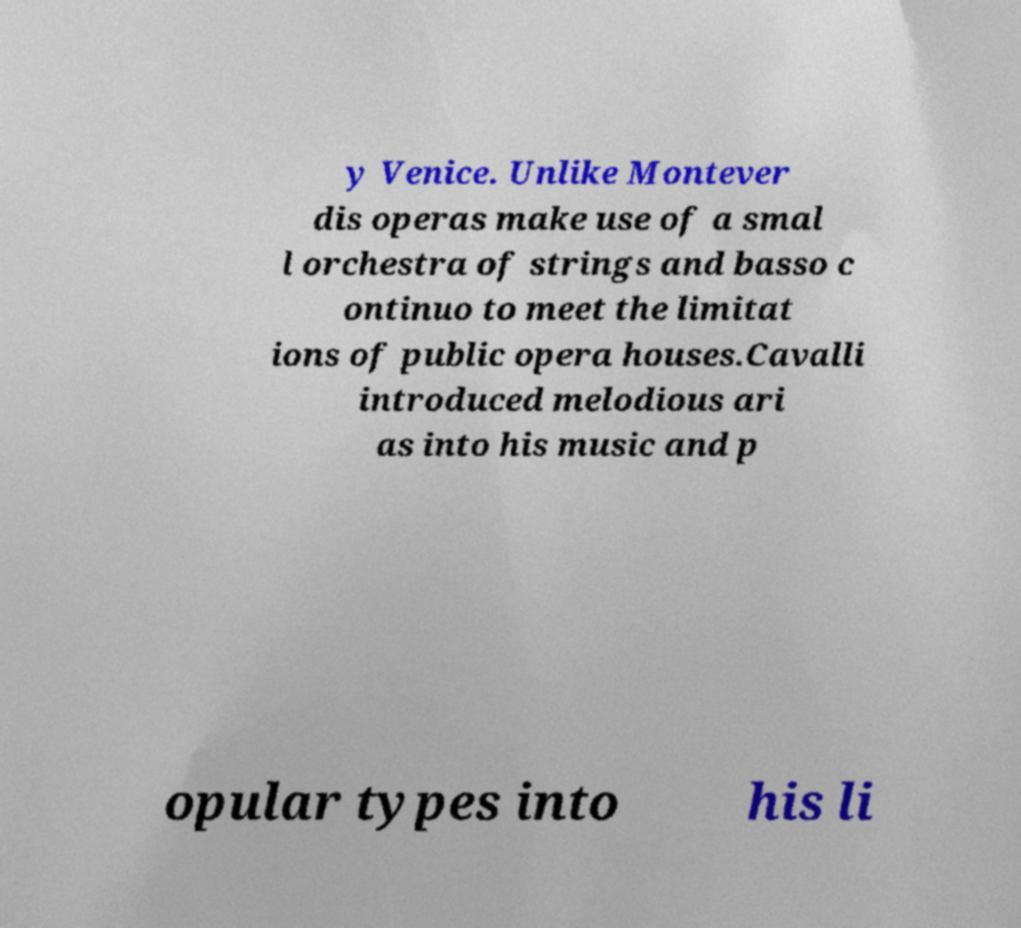Can you read and provide the text displayed in the image?This photo seems to have some interesting text. Can you extract and type it out for me? y Venice. Unlike Montever dis operas make use of a smal l orchestra of strings and basso c ontinuo to meet the limitat ions of public opera houses.Cavalli introduced melodious ari as into his music and p opular types into his li 